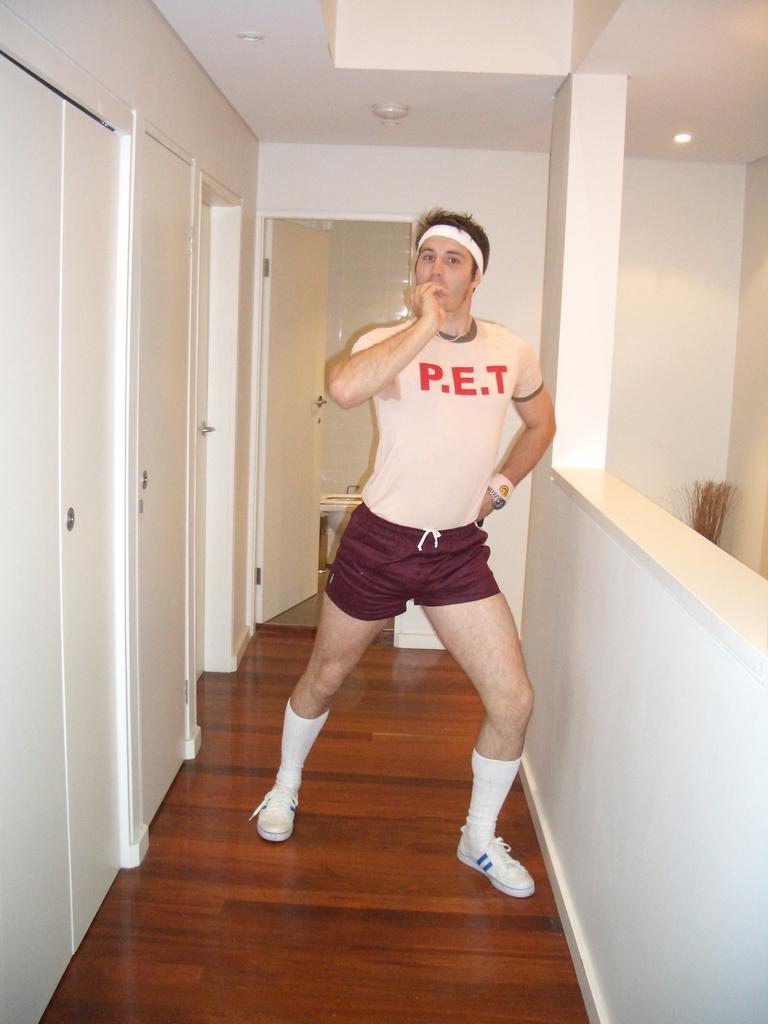<image>
Create a compact narrative representing the image presented. A guy wearing a shirt that says P.E.T. 